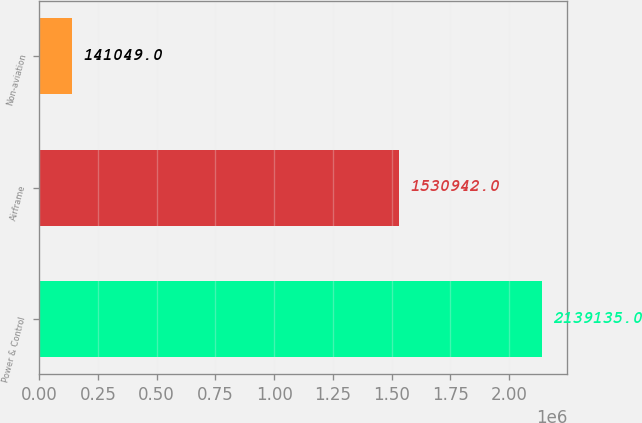Convert chart. <chart><loc_0><loc_0><loc_500><loc_500><bar_chart><fcel>Power & Control<fcel>Airframe<fcel>Non-aviation<nl><fcel>2.13914e+06<fcel>1.53094e+06<fcel>141049<nl></chart> 